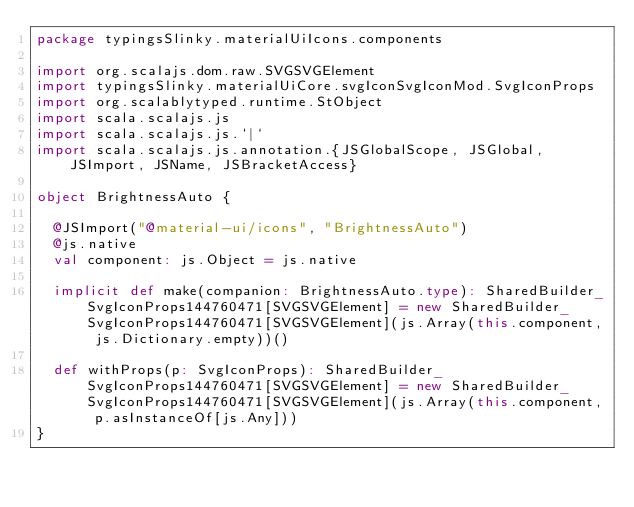<code> <loc_0><loc_0><loc_500><loc_500><_Scala_>package typingsSlinky.materialUiIcons.components

import org.scalajs.dom.raw.SVGSVGElement
import typingsSlinky.materialUiCore.svgIconSvgIconMod.SvgIconProps
import org.scalablytyped.runtime.StObject
import scala.scalajs.js
import scala.scalajs.js.`|`
import scala.scalajs.js.annotation.{JSGlobalScope, JSGlobal, JSImport, JSName, JSBracketAccess}

object BrightnessAuto {
  
  @JSImport("@material-ui/icons", "BrightnessAuto")
  @js.native
  val component: js.Object = js.native
  
  implicit def make(companion: BrightnessAuto.type): SharedBuilder_SvgIconProps144760471[SVGSVGElement] = new SharedBuilder_SvgIconProps144760471[SVGSVGElement](js.Array(this.component, js.Dictionary.empty))()
  
  def withProps(p: SvgIconProps): SharedBuilder_SvgIconProps144760471[SVGSVGElement] = new SharedBuilder_SvgIconProps144760471[SVGSVGElement](js.Array(this.component, p.asInstanceOf[js.Any]))
}
</code> 